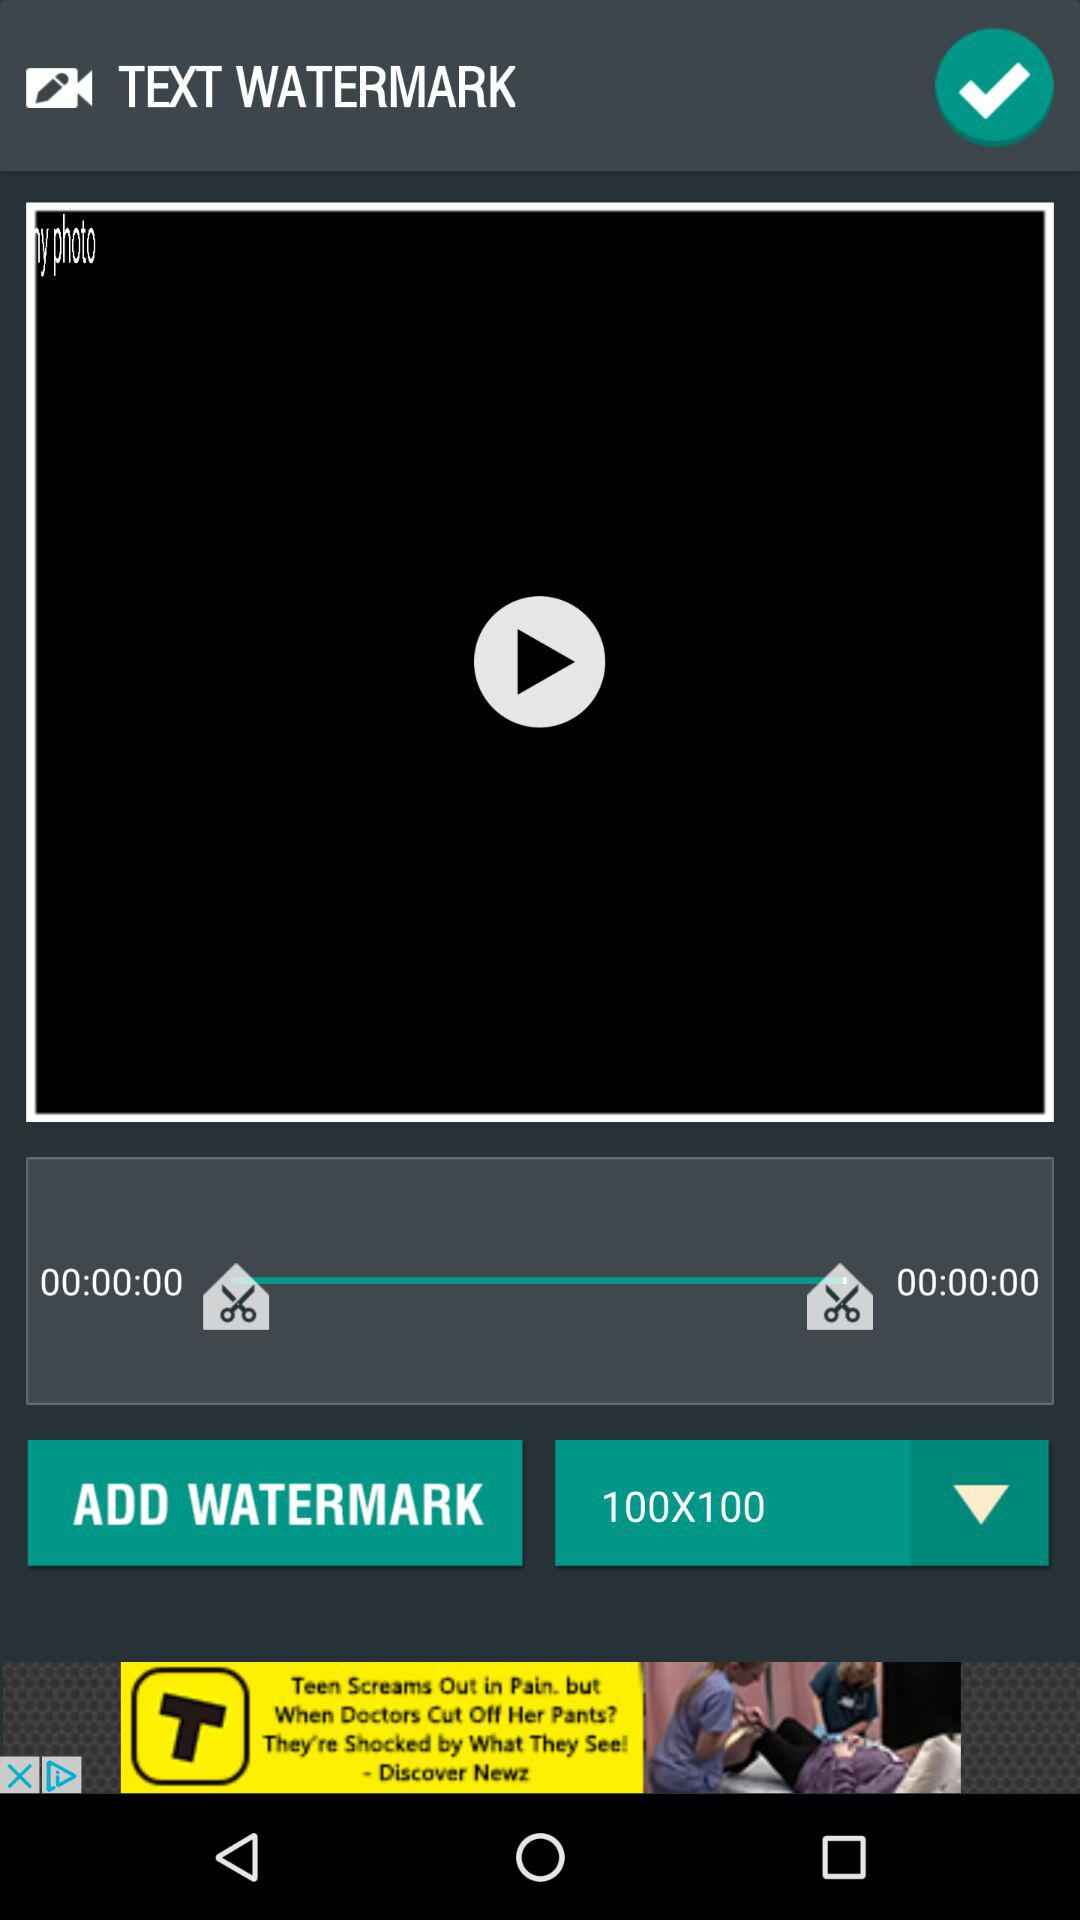How many seconds long is the video?
Answer the question using a single word or phrase. 00:00:00 